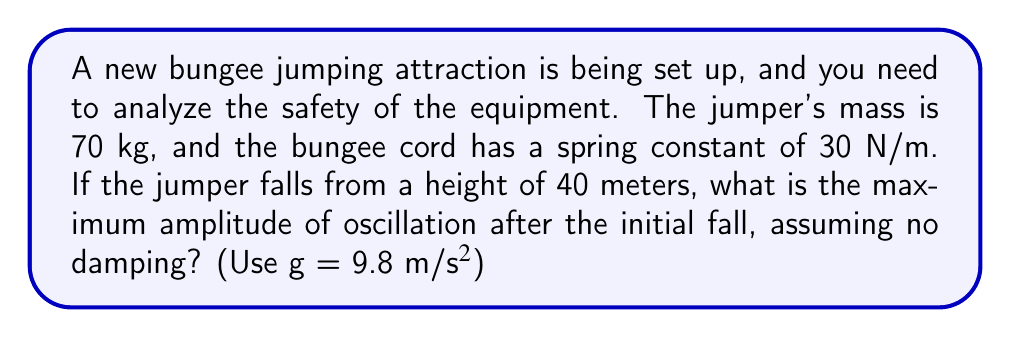Provide a solution to this math problem. To solve this problem, we'll use the principles of simple harmonic motion and conservation of energy. Let's break it down step-by-step:

1) First, we need to find the equilibrium position of the jumper. This is where the spring force equals the gravitational force:

   $F_{spring} = F_{gravity}$
   $kx = mg$
   $x = \frac{mg}{k} = \frac{70 \times 9.8}{30} = 22.87$ m

2) The jumper falls from 40 m, so the total distance traveled from the initial position to the lowest point is:

   $40 + 22.87 = 62.87$ m

3) Now, we can use conservation of energy. At the highest point, all energy is potential. At the lowest point, all energy is converted to elastic potential energy in the spring:

   $mgh = \frac{1}{2}kA^2$

   Where $h$ is the total distance traveled and $A$ is the amplitude we're looking for.

4) Substituting our values:

   $70 \times 9.8 \times 62.87 = \frac{1}{2} \times 30 \times A^2$

5) Solving for $A$:

   $A^2 = \frac{2 \times 70 \times 9.8 \times 62.87}{30} = 2880.95$
   $A = \sqrt{2880.95} = 53.67$ m

6) This amplitude is measured from the equilibrium position. To get the maximum displacement from the initial position, we subtract the equilibrium position:

   $53.67 - 22.87 = 30.80$ m

Therefore, the maximum amplitude of oscillation after the initial fall is approximately 30.80 meters below the initial jump point.
Answer: 30.80 m 